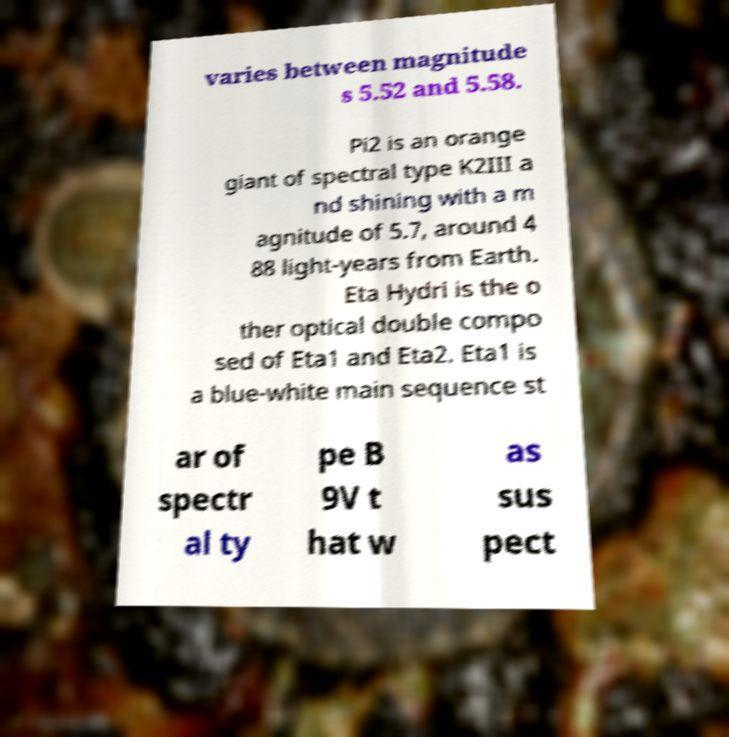Could you assist in decoding the text presented in this image and type it out clearly? varies between magnitude s 5.52 and 5.58. Pi2 is an orange giant of spectral type K2III a nd shining with a m agnitude of 5.7, around 4 88 light-years from Earth. Eta Hydri is the o ther optical double compo sed of Eta1 and Eta2. Eta1 is a blue-white main sequence st ar of spectr al ty pe B 9V t hat w as sus pect 